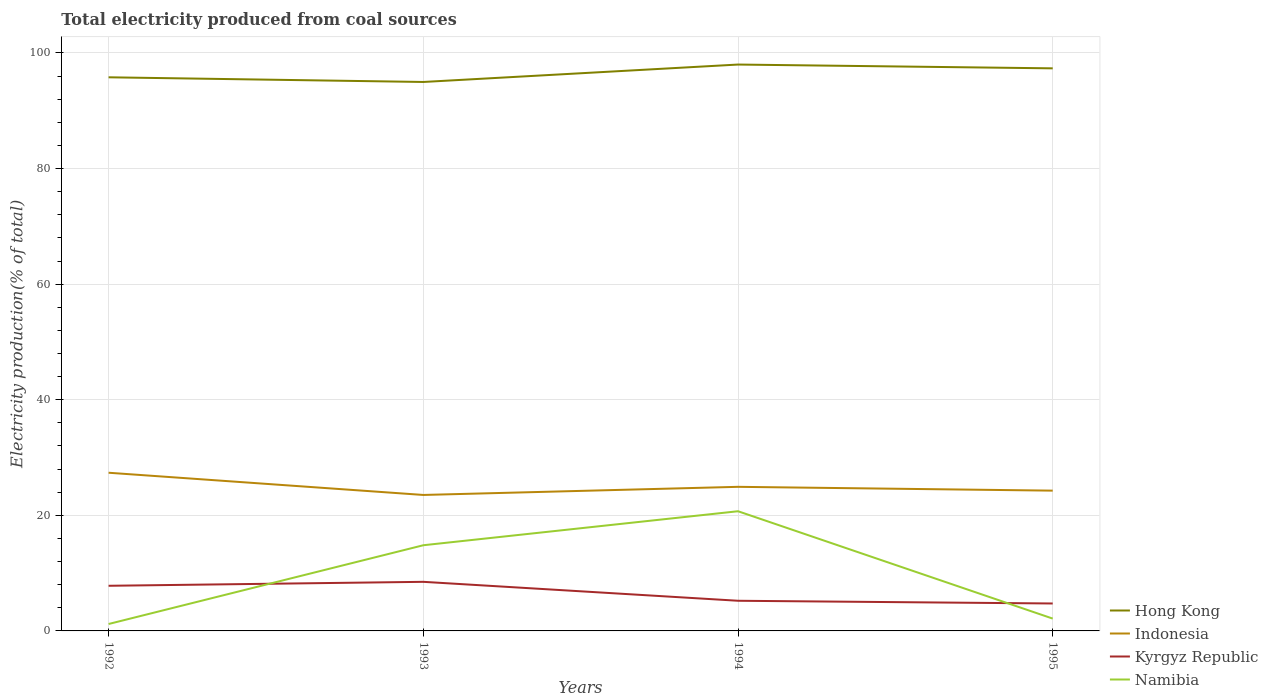Does the line corresponding to Kyrgyz Republic intersect with the line corresponding to Namibia?
Provide a short and direct response. Yes. Across all years, what is the maximum total electricity produced in Namibia?
Your answer should be compact. 1.2. What is the total total electricity produced in Indonesia in the graph?
Your answer should be very brief. 2.44. What is the difference between the highest and the second highest total electricity produced in Namibia?
Provide a short and direct response. 19.51. Is the total electricity produced in Indonesia strictly greater than the total electricity produced in Hong Kong over the years?
Offer a very short reply. Yes. How many years are there in the graph?
Provide a short and direct response. 4. Are the values on the major ticks of Y-axis written in scientific E-notation?
Your answer should be very brief. No. Does the graph contain any zero values?
Your response must be concise. No. Where does the legend appear in the graph?
Make the answer very short. Bottom right. How many legend labels are there?
Offer a terse response. 4. What is the title of the graph?
Make the answer very short. Total electricity produced from coal sources. Does "United States" appear as one of the legend labels in the graph?
Ensure brevity in your answer.  No. What is the label or title of the X-axis?
Ensure brevity in your answer.  Years. What is the Electricity production(% of total) in Hong Kong in 1992?
Your answer should be very brief. 95.79. What is the Electricity production(% of total) of Indonesia in 1992?
Give a very brief answer. 27.37. What is the Electricity production(% of total) of Kyrgyz Republic in 1992?
Ensure brevity in your answer.  7.81. What is the Electricity production(% of total) of Namibia in 1992?
Keep it short and to the point. 1.2. What is the Electricity production(% of total) in Hong Kong in 1993?
Provide a short and direct response. 94.98. What is the Electricity production(% of total) in Indonesia in 1993?
Your answer should be very brief. 23.53. What is the Electricity production(% of total) in Kyrgyz Republic in 1993?
Your answer should be compact. 8.5. What is the Electricity production(% of total) of Namibia in 1993?
Ensure brevity in your answer.  14.82. What is the Electricity production(% of total) in Hong Kong in 1994?
Provide a succinct answer. 98. What is the Electricity production(% of total) of Indonesia in 1994?
Offer a very short reply. 24.93. What is the Electricity production(% of total) of Kyrgyz Republic in 1994?
Your answer should be very brief. 5.22. What is the Electricity production(% of total) of Namibia in 1994?
Offer a very short reply. 20.71. What is the Electricity production(% of total) in Hong Kong in 1995?
Offer a very short reply. 97.34. What is the Electricity production(% of total) of Indonesia in 1995?
Make the answer very short. 24.27. What is the Electricity production(% of total) in Kyrgyz Republic in 1995?
Offer a terse response. 4.75. What is the Electricity production(% of total) in Namibia in 1995?
Provide a short and direct response. 2.13. Across all years, what is the maximum Electricity production(% of total) in Hong Kong?
Offer a terse response. 98. Across all years, what is the maximum Electricity production(% of total) in Indonesia?
Keep it short and to the point. 27.37. Across all years, what is the maximum Electricity production(% of total) of Kyrgyz Republic?
Provide a short and direct response. 8.5. Across all years, what is the maximum Electricity production(% of total) of Namibia?
Provide a short and direct response. 20.71. Across all years, what is the minimum Electricity production(% of total) in Hong Kong?
Provide a short and direct response. 94.98. Across all years, what is the minimum Electricity production(% of total) of Indonesia?
Keep it short and to the point. 23.53. Across all years, what is the minimum Electricity production(% of total) in Kyrgyz Republic?
Give a very brief answer. 4.75. Across all years, what is the minimum Electricity production(% of total) in Namibia?
Provide a short and direct response. 1.2. What is the total Electricity production(% of total) of Hong Kong in the graph?
Give a very brief answer. 386.12. What is the total Electricity production(% of total) of Indonesia in the graph?
Offer a very short reply. 100.1. What is the total Electricity production(% of total) in Kyrgyz Republic in the graph?
Ensure brevity in your answer.  26.27. What is the total Electricity production(% of total) in Namibia in the graph?
Make the answer very short. 38.87. What is the difference between the Electricity production(% of total) of Hong Kong in 1992 and that in 1993?
Your response must be concise. 0.81. What is the difference between the Electricity production(% of total) of Indonesia in 1992 and that in 1993?
Give a very brief answer. 3.84. What is the difference between the Electricity production(% of total) in Kyrgyz Republic in 1992 and that in 1993?
Offer a very short reply. -0.69. What is the difference between the Electricity production(% of total) of Namibia in 1992 and that in 1993?
Keep it short and to the point. -13.63. What is the difference between the Electricity production(% of total) of Hong Kong in 1992 and that in 1994?
Provide a short and direct response. -2.2. What is the difference between the Electricity production(% of total) of Indonesia in 1992 and that in 1994?
Make the answer very short. 2.44. What is the difference between the Electricity production(% of total) in Kyrgyz Republic in 1992 and that in 1994?
Your response must be concise. 2.59. What is the difference between the Electricity production(% of total) in Namibia in 1992 and that in 1994?
Provide a short and direct response. -19.51. What is the difference between the Electricity production(% of total) in Hong Kong in 1992 and that in 1995?
Keep it short and to the point. -1.55. What is the difference between the Electricity production(% of total) in Indonesia in 1992 and that in 1995?
Your answer should be compact. 3.1. What is the difference between the Electricity production(% of total) in Kyrgyz Republic in 1992 and that in 1995?
Make the answer very short. 3.06. What is the difference between the Electricity production(% of total) in Namibia in 1992 and that in 1995?
Provide a succinct answer. -0.94. What is the difference between the Electricity production(% of total) of Hong Kong in 1993 and that in 1994?
Offer a terse response. -3.01. What is the difference between the Electricity production(% of total) in Indonesia in 1993 and that in 1994?
Make the answer very short. -1.41. What is the difference between the Electricity production(% of total) of Kyrgyz Republic in 1993 and that in 1994?
Offer a terse response. 3.28. What is the difference between the Electricity production(% of total) in Namibia in 1993 and that in 1994?
Your answer should be very brief. -5.88. What is the difference between the Electricity production(% of total) in Hong Kong in 1993 and that in 1995?
Your answer should be very brief. -2.36. What is the difference between the Electricity production(% of total) of Indonesia in 1993 and that in 1995?
Ensure brevity in your answer.  -0.74. What is the difference between the Electricity production(% of total) in Kyrgyz Republic in 1993 and that in 1995?
Your response must be concise. 3.75. What is the difference between the Electricity production(% of total) in Namibia in 1993 and that in 1995?
Ensure brevity in your answer.  12.69. What is the difference between the Electricity production(% of total) in Hong Kong in 1994 and that in 1995?
Provide a short and direct response. 0.66. What is the difference between the Electricity production(% of total) in Indonesia in 1994 and that in 1995?
Your answer should be very brief. 0.66. What is the difference between the Electricity production(% of total) in Kyrgyz Republic in 1994 and that in 1995?
Provide a succinct answer. 0.47. What is the difference between the Electricity production(% of total) of Namibia in 1994 and that in 1995?
Your response must be concise. 18.57. What is the difference between the Electricity production(% of total) in Hong Kong in 1992 and the Electricity production(% of total) in Indonesia in 1993?
Provide a succinct answer. 72.27. What is the difference between the Electricity production(% of total) of Hong Kong in 1992 and the Electricity production(% of total) of Kyrgyz Republic in 1993?
Ensure brevity in your answer.  87.3. What is the difference between the Electricity production(% of total) in Hong Kong in 1992 and the Electricity production(% of total) in Namibia in 1993?
Make the answer very short. 80.97. What is the difference between the Electricity production(% of total) in Indonesia in 1992 and the Electricity production(% of total) in Kyrgyz Republic in 1993?
Make the answer very short. 18.87. What is the difference between the Electricity production(% of total) of Indonesia in 1992 and the Electricity production(% of total) of Namibia in 1993?
Ensure brevity in your answer.  12.55. What is the difference between the Electricity production(% of total) of Kyrgyz Republic in 1992 and the Electricity production(% of total) of Namibia in 1993?
Offer a terse response. -7.01. What is the difference between the Electricity production(% of total) of Hong Kong in 1992 and the Electricity production(% of total) of Indonesia in 1994?
Make the answer very short. 70.86. What is the difference between the Electricity production(% of total) of Hong Kong in 1992 and the Electricity production(% of total) of Kyrgyz Republic in 1994?
Offer a very short reply. 90.58. What is the difference between the Electricity production(% of total) of Hong Kong in 1992 and the Electricity production(% of total) of Namibia in 1994?
Keep it short and to the point. 75.09. What is the difference between the Electricity production(% of total) of Indonesia in 1992 and the Electricity production(% of total) of Kyrgyz Republic in 1994?
Make the answer very short. 22.15. What is the difference between the Electricity production(% of total) in Indonesia in 1992 and the Electricity production(% of total) in Namibia in 1994?
Provide a succinct answer. 6.66. What is the difference between the Electricity production(% of total) in Kyrgyz Republic in 1992 and the Electricity production(% of total) in Namibia in 1994?
Give a very brief answer. -12.9. What is the difference between the Electricity production(% of total) in Hong Kong in 1992 and the Electricity production(% of total) in Indonesia in 1995?
Provide a succinct answer. 71.52. What is the difference between the Electricity production(% of total) of Hong Kong in 1992 and the Electricity production(% of total) of Kyrgyz Republic in 1995?
Keep it short and to the point. 91.05. What is the difference between the Electricity production(% of total) in Hong Kong in 1992 and the Electricity production(% of total) in Namibia in 1995?
Provide a succinct answer. 93.66. What is the difference between the Electricity production(% of total) in Indonesia in 1992 and the Electricity production(% of total) in Kyrgyz Republic in 1995?
Make the answer very short. 22.62. What is the difference between the Electricity production(% of total) of Indonesia in 1992 and the Electricity production(% of total) of Namibia in 1995?
Provide a short and direct response. 25.23. What is the difference between the Electricity production(% of total) of Kyrgyz Republic in 1992 and the Electricity production(% of total) of Namibia in 1995?
Offer a terse response. 5.68. What is the difference between the Electricity production(% of total) in Hong Kong in 1993 and the Electricity production(% of total) in Indonesia in 1994?
Give a very brief answer. 70.05. What is the difference between the Electricity production(% of total) of Hong Kong in 1993 and the Electricity production(% of total) of Kyrgyz Republic in 1994?
Offer a very short reply. 89.77. What is the difference between the Electricity production(% of total) in Hong Kong in 1993 and the Electricity production(% of total) in Namibia in 1994?
Your response must be concise. 74.28. What is the difference between the Electricity production(% of total) of Indonesia in 1993 and the Electricity production(% of total) of Kyrgyz Republic in 1994?
Give a very brief answer. 18.31. What is the difference between the Electricity production(% of total) of Indonesia in 1993 and the Electricity production(% of total) of Namibia in 1994?
Make the answer very short. 2.82. What is the difference between the Electricity production(% of total) of Kyrgyz Republic in 1993 and the Electricity production(% of total) of Namibia in 1994?
Your answer should be very brief. -12.21. What is the difference between the Electricity production(% of total) in Hong Kong in 1993 and the Electricity production(% of total) in Indonesia in 1995?
Offer a terse response. 70.71. What is the difference between the Electricity production(% of total) in Hong Kong in 1993 and the Electricity production(% of total) in Kyrgyz Republic in 1995?
Your answer should be very brief. 90.24. What is the difference between the Electricity production(% of total) in Hong Kong in 1993 and the Electricity production(% of total) in Namibia in 1995?
Provide a short and direct response. 92.85. What is the difference between the Electricity production(% of total) of Indonesia in 1993 and the Electricity production(% of total) of Kyrgyz Republic in 1995?
Your answer should be very brief. 18.78. What is the difference between the Electricity production(% of total) in Indonesia in 1993 and the Electricity production(% of total) in Namibia in 1995?
Your answer should be compact. 21.39. What is the difference between the Electricity production(% of total) in Kyrgyz Republic in 1993 and the Electricity production(% of total) in Namibia in 1995?
Your answer should be very brief. 6.36. What is the difference between the Electricity production(% of total) in Hong Kong in 1994 and the Electricity production(% of total) in Indonesia in 1995?
Offer a terse response. 73.73. What is the difference between the Electricity production(% of total) of Hong Kong in 1994 and the Electricity production(% of total) of Kyrgyz Republic in 1995?
Ensure brevity in your answer.  93.25. What is the difference between the Electricity production(% of total) in Hong Kong in 1994 and the Electricity production(% of total) in Namibia in 1995?
Offer a very short reply. 95.86. What is the difference between the Electricity production(% of total) in Indonesia in 1994 and the Electricity production(% of total) in Kyrgyz Republic in 1995?
Your answer should be compact. 20.19. What is the difference between the Electricity production(% of total) of Indonesia in 1994 and the Electricity production(% of total) of Namibia in 1995?
Make the answer very short. 22.8. What is the difference between the Electricity production(% of total) in Kyrgyz Republic in 1994 and the Electricity production(% of total) in Namibia in 1995?
Keep it short and to the point. 3.08. What is the average Electricity production(% of total) in Hong Kong per year?
Your answer should be compact. 96.53. What is the average Electricity production(% of total) in Indonesia per year?
Offer a terse response. 25.03. What is the average Electricity production(% of total) in Kyrgyz Republic per year?
Keep it short and to the point. 6.57. What is the average Electricity production(% of total) of Namibia per year?
Ensure brevity in your answer.  9.72. In the year 1992, what is the difference between the Electricity production(% of total) of Hong Kong and Electricity production(% of total) of Indonesia?
Your response must be concise. 68.42. In the year 1992, what is the difference between the Electricity production(% of total) in Hong Kong and Electricity production(% of total) in Kyrgyz Republic?
Your response must be concise. 87.98. In the year 1992, what is the difference between the Electricity production(% of total) in Hong Kong and Electricity production(% of total) in Namibia?
Provide a succinct answer. 94.6. In the year 1992, what is the difference between the Electricity production(% of total) of Indonesia and Electricity production(% of total) of Kyrgyz Republic?
Your answer should be very brief. 19.56. In the year 1992, what is the difference between the Electricity production(% of total) of Indonesia and Electricity production(% of total) of Namibia?
Make the answer very short. 26.17. In the year 1992, what is the difference between the Electricity production(% of total) in Kyrgyz Republic and Electricity production(% of total) in Namibia?
Give a very brief answer. 6.61. In the year 1993, what is the difference between the Electricity production(% of total) in Hong Kong and Electricity production(% of total) in Indonesia?
Your answer should be very brief. 71.46. In the year 1993, what is the difference between the Electricity production(% of total) of Hong Kong and Electricity production(% of total) of Kyrgyz Republic?
Ensure brevity in your answer.  86.49. In the year 1993, what is the difference between the Electricity production(% of total) in Hong Kong and Electricity production(% of total) in Namibia?
Your answer should be very brief. 80.16. In the year 1993, what is the difference between the Electricity production(% of total) in Indonesia and Electricity production(% of total) in Kyrgyz Republic?
Your response must be concise. 15.03. In the year 1993, what is the difference between the Electricity production(% of total) of Indonesia and Electricity production(% of total) of Namibia?
Offer a very short reply. 8.7. In the year 1993, what is the difference between the Electricity production(% of total) of Kyrgyz Republic and Electricity production(% of total) of Namibia?
Make the answer very short. -6.33. In the year 1994, what is the difference between the Electricity production(% of total) in Hong Kong and Electricity production(% of total) in Indonesia?
Your response must be concise. 73.07. In the year 1994, what is the difference between the Electricity production(% of total) of Hong Kong and Electricity production(% of total) of Kyrgyz Republic?
Give a very brief answer. 92.78. In the year 1994, what is the difference between the Electricity production(% of total) in Hong Kong and Electricity production(% of total) in Namibia?
Ensure brevity in your answer.  77.29. In the year 1994, what is the difference between the Electricity production(% of total) of Indonesia and Electricity production(% of total) of Kyrgyz Republic?
Give a very brief answer. 19.71. In the year 1994, what is the difference between the Electricity production(% of total) in Indonesia and Electricity production(% of total) in Namibia?
Keep it short and to the point. 4.22. In the year 1994, what is the difference between the Electricity production(% of total) in Kyrgyz Republic and Electricity production(% of total) in Namibia?
Your answer should be very brief. -15.49. In the year 1995, what is the difference between the Electricity production(% of total) of Hong Kong and Electricity production(% of total) of Indonesia?
Give a very brief answer. 73.07. In the year 1995, what is the difference between the Electricity production(% of total) in Hong Kong and Electricity production(% of total) in Kyrgyz Republic?
Your answer should be very brief. 92.6. In the year 1995, what is the difference between the Electricity production(% of total) in Hong Kong and Electricity production(% of total) in Namibia?
Provide a succinct answer. 95.21. In the year 1995, what is the difference between the Electricity production(% of total) of Indonesia and Electricity production(% of total) of Kyrgyz Republic?
Keep it short and to the point. 19.53. In the year 1995, what is the difference between the Electricity production(% of total) in Indonesia and Electricity production(% of total) in Namibia?
Give a very brief answer. 22.14. In the year 1995, what is the difference between the Electricity production(% of total) of Kyrgyz Republic and Electricity production(% of total) of Namibia?
Offer a terse response. 2.61. What is the ratio of the Electricity production(% of total) of Hong Kong in 1992 to that in 1993?
Your answer should be compact. 1.01. What is the ratio of the Electricity production(% of total) of Indonesia in 1992 to that in 1993?
Give a very brief answer. 1.16. What is the ratio of the Electricity production(% of total) in Kyrgyz Republic in 1992 to that in 1993?
Offer a very short reply. 0.92. What is the ratio of the Electricity production(% of total) of Namibia in 1992 to that in 1993?
Make the answer very short. 0.08. What is the ratio of the Electricity production(% of total) of Hong Kong in 1992 to that in 1994?
Provide a short and direct response. 0.98. What is the ratio of the Electricity production(% of total) of Indonesia in 1992 to that in 1994?
Your response must be concise. 1.1. What is the ratio of the Electricity production(% of total) of Kyrgyz Republic in 1992 to that in 1994?
Your answer should be compact. 1.5. What is the ratio of the Electricity production(% of total) in Namibia in 1992 to that in 1994?
Keep it short and to the point. 0.06. What is the ratio of the Electricity production(% of total) of Hong Kong in 1992 to that in 1995?
Provide a succinct answer. 0.98. What is the ratio of the Electricity production(% of total) in Indonesia in 1992 to that in 1995?
Ensure brevity in your answer.  1.13. What is the ratio of the Electricity production(% of total) in Kyrgyz Republic in 1992 to that in 1995?
Offer a very short reply. 1.65. What is the ratio of the Electricity production(% of total) of Namibia in 1992 to that in 1995?
Ensure brevity in your answer.  0.56. What is the ratio of the Electricity production(% of total) in Hong Kong in 1993 to that in 1994?
Your answer should be very brief. 0.97. What is the ratio of the Electricity production(% of total) in Indonesia in 1993 to that in 1994?
Give a very brief answer. 0.94. What is the ratio of the Electricity production(% of total) in Kyrgyz Republic in 1993 to that in 1994?
Give a very brief answer. 1.63. What is the ratio of the Electricity production(% of total) in Namibia in 1993 to that in 1994?
Give a very brief answer. 0.72. What is the ratio of the Electricity production(% of total) in Hong Kong in 1993 to that in 1995?
Ensure brevity in your answer.  0.98. What is the ratio of the Electricity production(% of total) of Indonesia in 1993 to that in 1995?
Your answer should be very brief. 0.97. What is the ratio of the Electricity production(% of total) of Kyrgyz Republic in 1993 to that in 1995?
Offer a terse response. 1.79. What is the ratio of the Electricity production(% of total) of Namibia in 1993 to that in 1995?
Give a very brief answer. 6.94. What is the ratio of the Electricity production(% of total) in Hong Kong in 1994 to that in 1995?
Provide a short and direct response. 1.01. What is the ratio of the Electricity production(% of total) of Indonesia in 1994 to that in 1995?
Your response must be concise. 1.03. What is the ratio of the Electricity production(% of total) of Kyrgyz Republic in 1994 to that in 1995?
Your response must be concise. 1.1. What is the ratio of the Electricity production(% of total) in Namibia in 1994 to that in 1995?
Your answer should be compact. 9.7. What is the difference between the highest and the second highest Electricity production(% of total) in Hong Kong?
Provide a succinct answer. 0.66. What is the difference between the highest and the second highest Electricity production(% of total) of Indonesia?
Your answer should be very brief. 2.44. What is the difference between the highest and the second highest Electricity production(% of total) of Kyrgyz Republic?
Your response must be concise. 0.69. What is the difference between the highest and the second highest Electricity production(% of total) in Namibia?
Keep it short and to the point. 5.88. What is the difference between the highest and the lowest Electricity production(% of total) in Hong Kong?
Provide a succinct answer. 3.01. What is the difference between the highest and the lowest Electricity production(% of total) of Indonesia?
Keep it short and to the point. 3.84. What is the difference between the highest and the lowest Electricity production(% of total) of Kyrgyz Republic?
Offer a terse response. 3.75. What is the difference between the highest and the lowest Electricity production(% of total) in Namibia?
Ensure brevity in your answer.  19.51. 